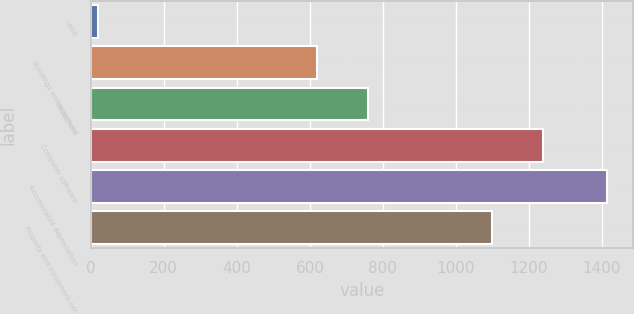Convert chart to OTSL. <chart><loc_0><loc_0><loc_500><loc_500><bar_chart><fcel>Land<fcel>Buildings and leasehold<fcel>Equipment<fcel>Computer software<fcel>Accumulated depreciation<fcel>Property and equipment net<nl><fcel>20<fcel>620<fcel>759.5<fcel>1237.5<fcel>1415<fcel>1098<nl></chart> 